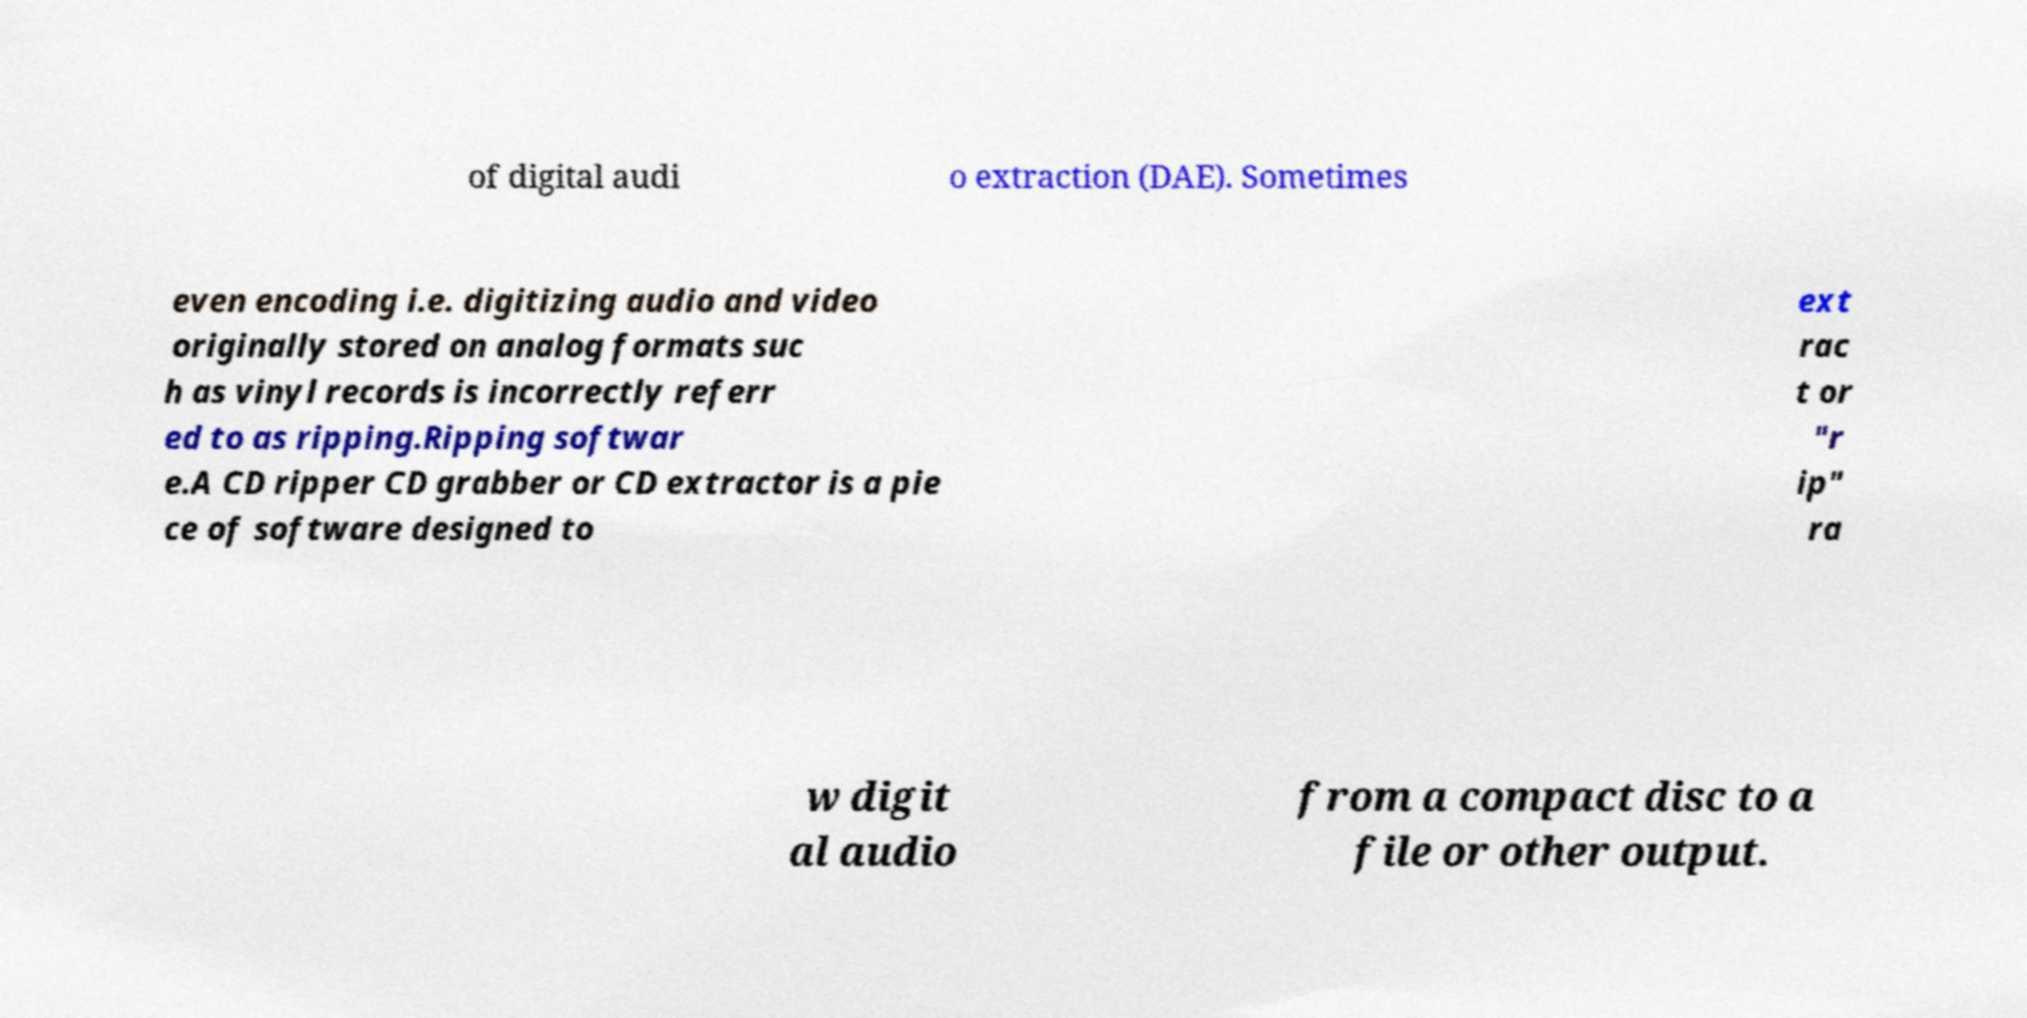For documentation purposes, I need the text within this image transcribed. Could you provide that? of digital audi o extraction (DAE). Sometimes even encoding i.e. digitizing audio and video originally stored on analog formats suc h as vinyl records is incorrectly referr ed to as ripping.Ripping softwar e.A CD ripper CD grabber or CD extractor is a pie ce of software designed to ext rac t or "r ip" ra w digit al audio from a compact disc to a file or other output. 